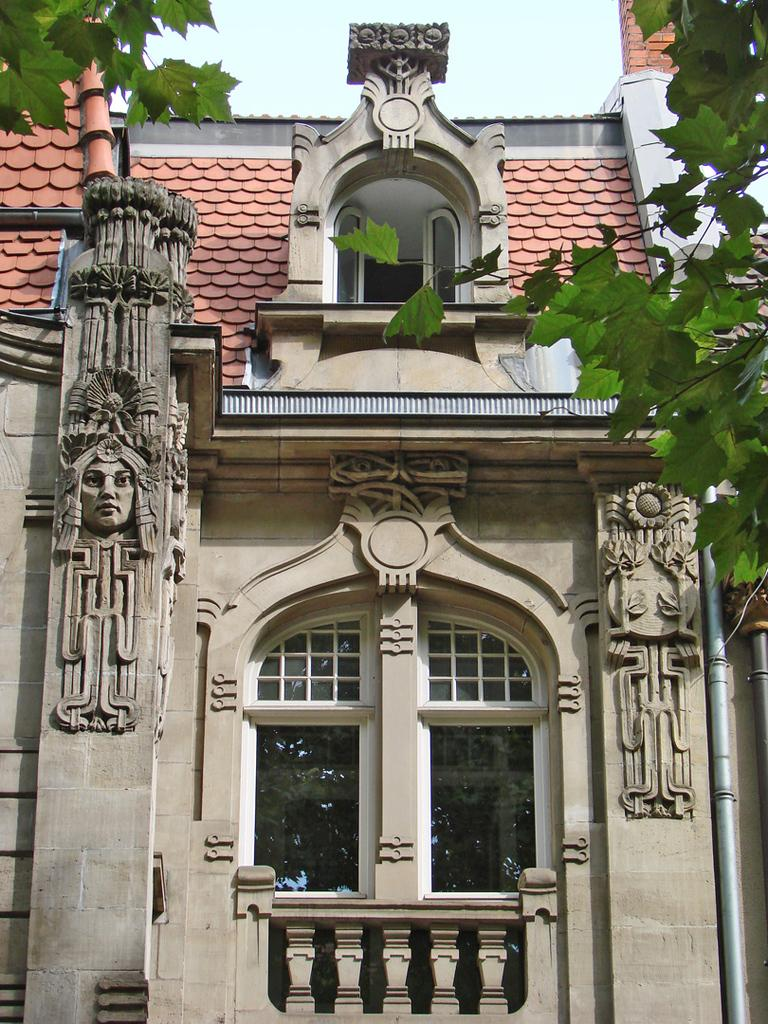What type of structure is visible in the image? There is a building in the image. What feature can be seen on the building? The building has windows. What artistic objects are present in the image? There are sculptures in the image. What type of vegetation is present in the image? Leaves are present in the image. What type of cake is being served in the image? There is no cake present in the image; it features a building, sculptures, and leaves. 